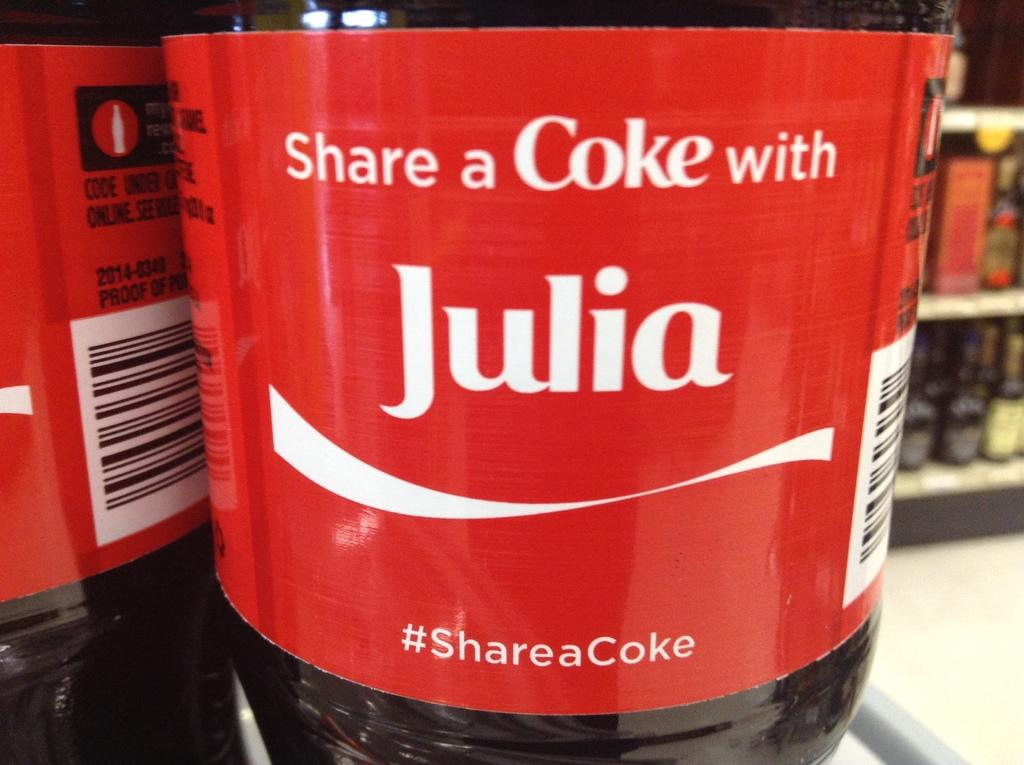Provide a one-sentence caption for the provided image. A Coke bottle label is personalized for someone named Julia. 